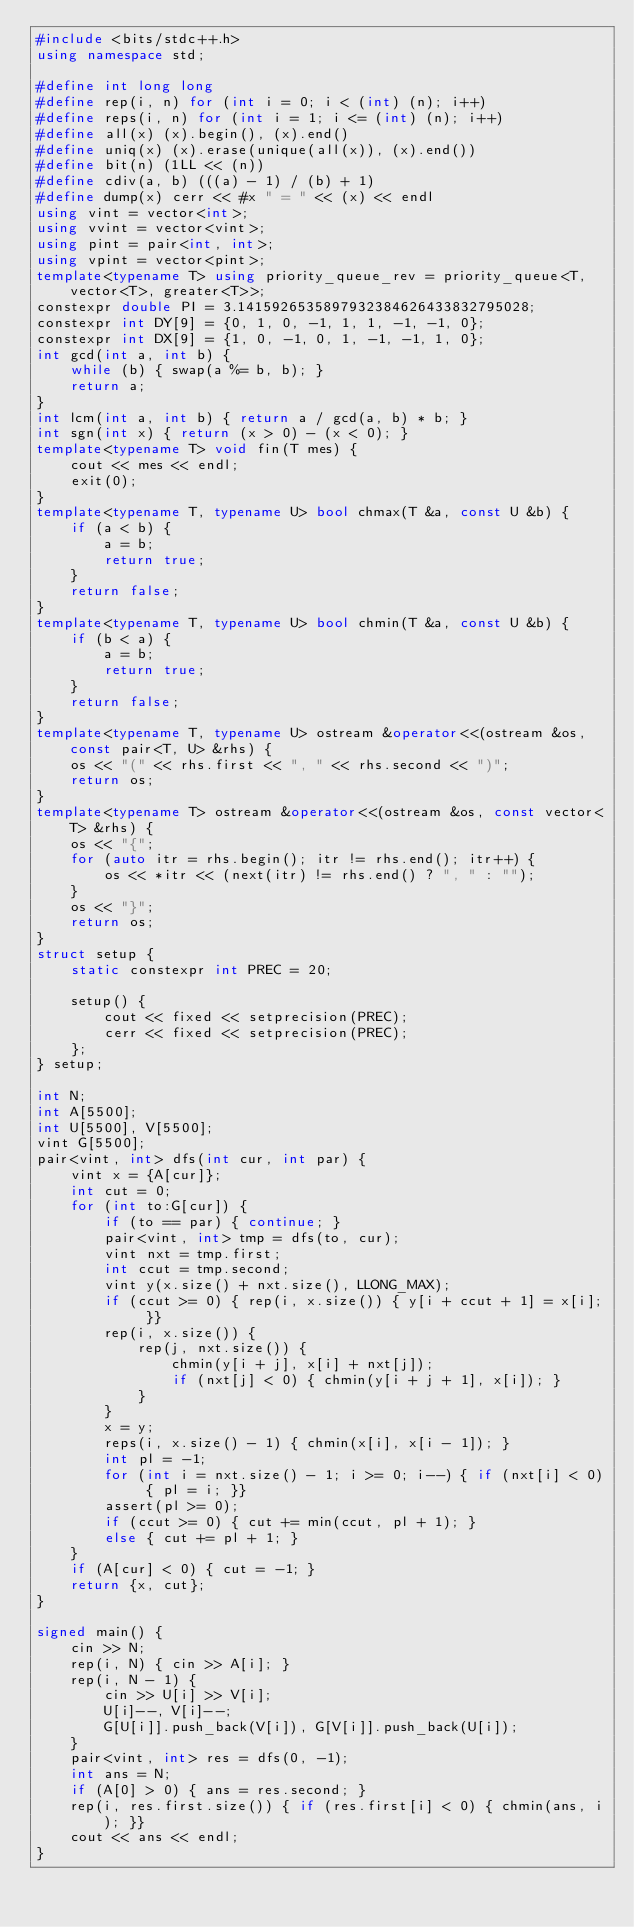<code> <loc_0><loc_0><loc_500><loc_500><_C++_>#include <bits/stdc++.h>
using namespace std;

#define int long long
#define rep(i, n) for (int i = 0; i < (int) (n); i++)
#define reps(i, n) for (int i = 1; i <= (int) (n); i++)
#define all(x) (x).begin(), (x).end()
#define uniq(x) (x).erase(unique(all(x)), (x).end())
#define bit(n) (1LL << (n))
#define cdiv(a, b) (((a) - 1) / (b) + 1)
#define dump(x) cerr << #x " = " << (x) << endl
using vint = vector<int>;
using vvint = vector<vint>;
using pint = pair<int, int>;
using vpint = vector<pint>;
template<typename T> using priority_queue_rev = priority_queue<T, vector<T>, greater<T>>;
constexpr double PI = 3.1415926535897932384626433832795028;
constexpr int DY[9] = {0, 1, 0, -1, 1, 1, -1, -1, 0};
constexpr int DX[9] = {1, 0, -1, 0, 1, -1, -1, 1, 0};
int gcd(int a, int b) {
    while (b) { swap(a %= b, b); }
    return a;
}
int lcm(int a, int b) { return a / gcd(a, b) * b; }
int sgn(int x) { return (x > 0) - (x < 0); }
template<typename T> void fin(T mes) {
    cout << mes << endl;
    exit(0);
}
template<typename T, typename U> bool chmax(T &a, const U &b) {
    if (a < b) {
        a = b;
        return true;
    }
    return false;
}
template<typename T, typename U> bool chmin(T &a, const U &b) {
    if (b < a) {
        a = b;
        return true;
    }
    return false;
}
template<typename T, typename U> ostream &operator<<(ostream &os, const pair<T, U> &rhs) {
    os << "(" << rhs.first << ", " << rhs.second << ")";
    return os;
}
template<typename T> ostream &operator<<(ostream &os, const vector<T> &rhs) {
    os << "{";
    for (auto itr = rhs.begin(); itr != rhs.end(); itr++) {
        os << *itr << (next(itr) != rhs.end() ? ", " : "");
    }
    os << "}";
    return os;
}
struct setup {
    static constexpr int PREC = 20;

    setup() {
        cout << fixed << setprecision(PREC);
        cerr << fixed << setprecision(PREC);
    };
} setup;

int N;
int A[5500];
int U[5500], V[5500];
vint G[5500];
pair<vint, int> dfs(int cur, int par) {
    vint x = {A[cur]};
    int cut = 0;
    for (int to:G[cur]) {
        if (to == par) { continue; }
        pair<vint, int> tmp = dfs(to, cur);
        vint nxt = tmp.first;
        int ccut = tmp.second;
        vint y(x.size() + nxt.size(), LLONG_MAX);
        if (ccut >= 0) { rep(i, x.size()) { y[i + ccut + 1] = x[i]; }}
        rep(i, x.size()) {
            rep(j, nxt.size()) {
                chmin(y[i + j], x[i] + nxt[j]);
                if (nxt[j] < 0) { chmin(y[i + j + 1], x[i]); }
            }
        }
        x = y;
        reps(i, x.size() - 1) { chmin(x[i], x[i - 1]); }
        int pl = -1;
        for (int i = nxt.size() - 1; i >= 0; i--) { if (nxt[i] < 0) { pl = i; }}
        assert(pl >= 0);
        if (ccut >= 0) { cut += min(ccut, pl + 1); }
        else { cut += pl + 1; }
    }
    if (A[cur] < 0) { cut = -1; }
    return {x, cut};
}

signed main() {
    cin >> N;
    rep(i, N) { cin >> A[i]; }
    rep(i, N - 1) {
        cin >> U[i] >> V[i];
        U[i]--, V[i]--;
        G[U[i]].push_back(V[i]), G[V[i]].push_back(U[i]);
    }
    pair<vint, int> res = dfs(0, -1);
    int ans = N;
    if (A[0] > 0) { ans = res.second; }
    rep(i, res.first.size()) { if (res.first[i] < 0) { chmin(ans, i); }}
    cout << ans << endl;
}</code> 